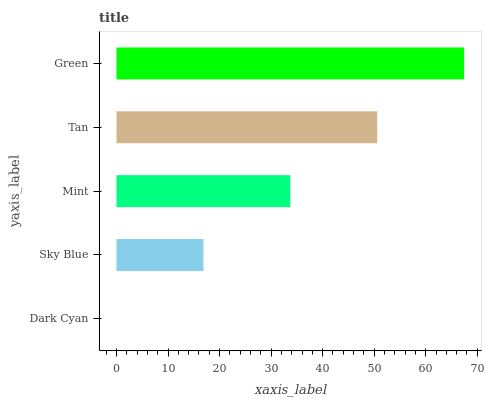Is Dark Cyan the minimum?
Answer yes or no. Yes. Is Green the maximum?
Answer yes or no. Yes. Is Sky Blue the minimum?
Answer yes or no. No. Is Sky Blue the maximum?
Answer yes or no. No. Is Sky Blue greater than Dark Cyan?
Answer yes or no. Yes. Is Dark Cyan less than Sky Blue?
Answer yes or no. Yes. Is Dark Cyan greater than Sky Blue?
Answer yes or no. No. Is Sky Blue less than Dark Cyan?
Answer yes or no. No. Is Mint the high median?
Answer yes or no. Yes. Is Mint the low median?
Answer yes or no. Yes. Is Dark Cyan the high median?
Answer yes or no. No. Is Sky Blue the low median?
Answer yes or no. No. 